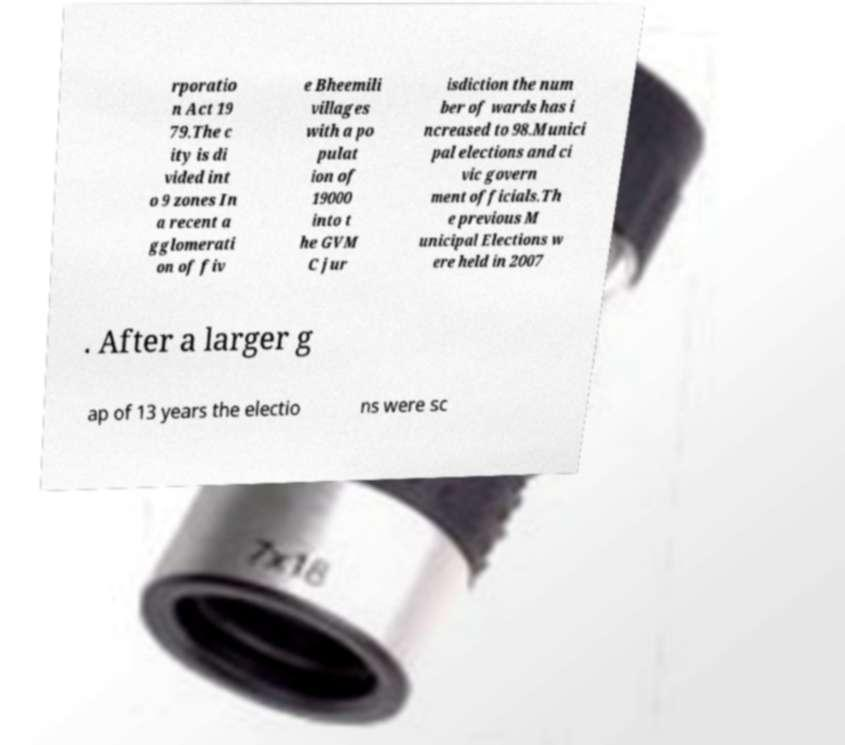Please read and relay the text visible in this image. What does it say? rporatio n Act 19 79.The c ity is di vided int o 9 zones In a recent a gglomerati on of fiv e Bheemili villages with a po pulat ion of 19000 into t he GVM C jur isdiction the num ber of wards has i ncreased to 98.Munici pal elections and ci vic govern ment officials.Th e previous M unicipal Elections w ere held in 2007 . After a larger g ap of 13 years the electio ns were sc 